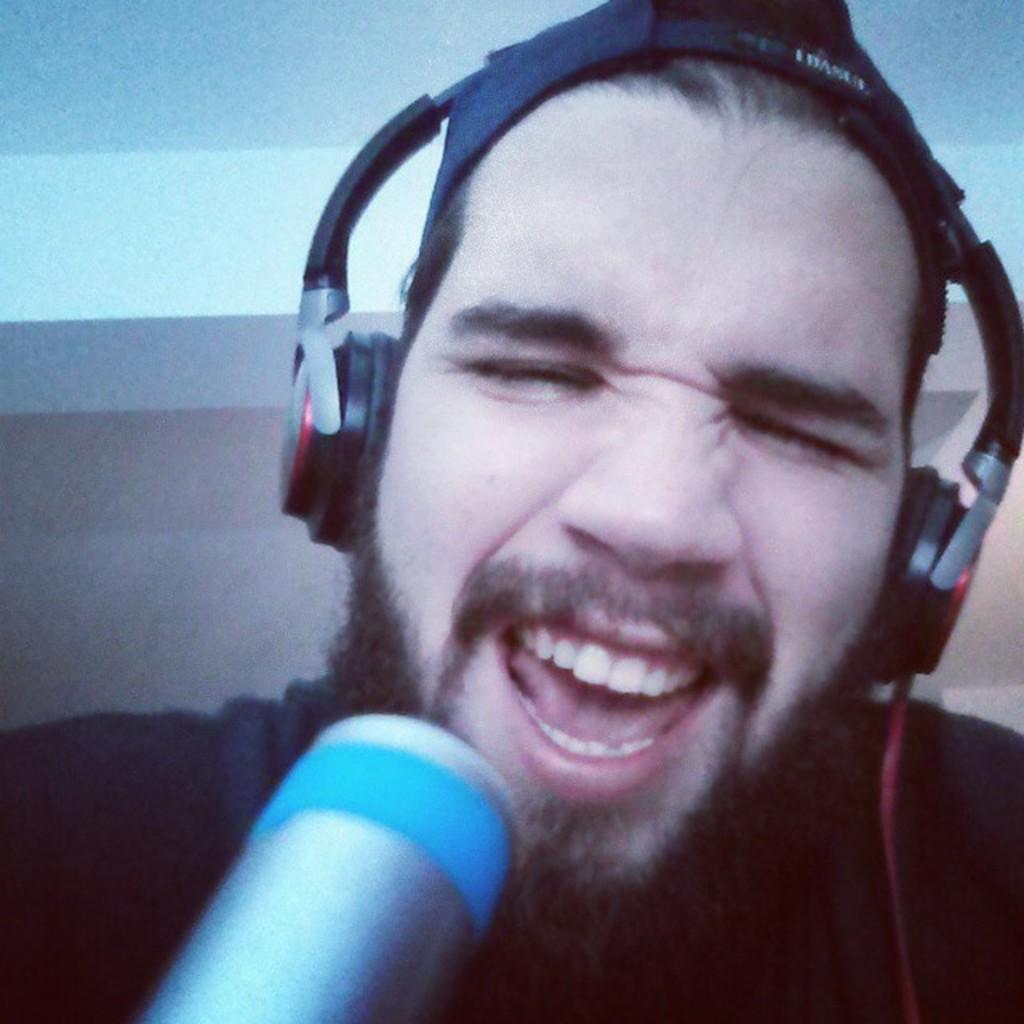Please provide a concise description of this image. In this picture, we can see a person with headset, and we can see some object in the bottom side of the picture, we can see the background. 